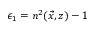<formula> <loc_0><loc_0><loc_500><loc_500>\epsilon _ { 1 } = n ^ { 2 } ( \vec { x } , z ) - 1</formula> 